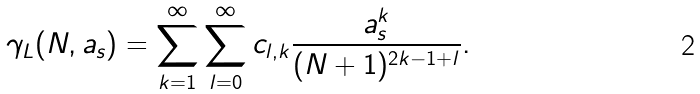<formula> <loc_0><loc_0><loc_500><loc_500>\gamma _ { L } ( N , a _ { s } ) = \sum _ { k = 1 } ^ { \infty } \sum _ { l = 0 } ^ { \infty } c _ { l , k } \frac { a _ { s } ^ { k } } { ( N + 1 ) ^ { 2 k - 1 + l } } .</formula> 